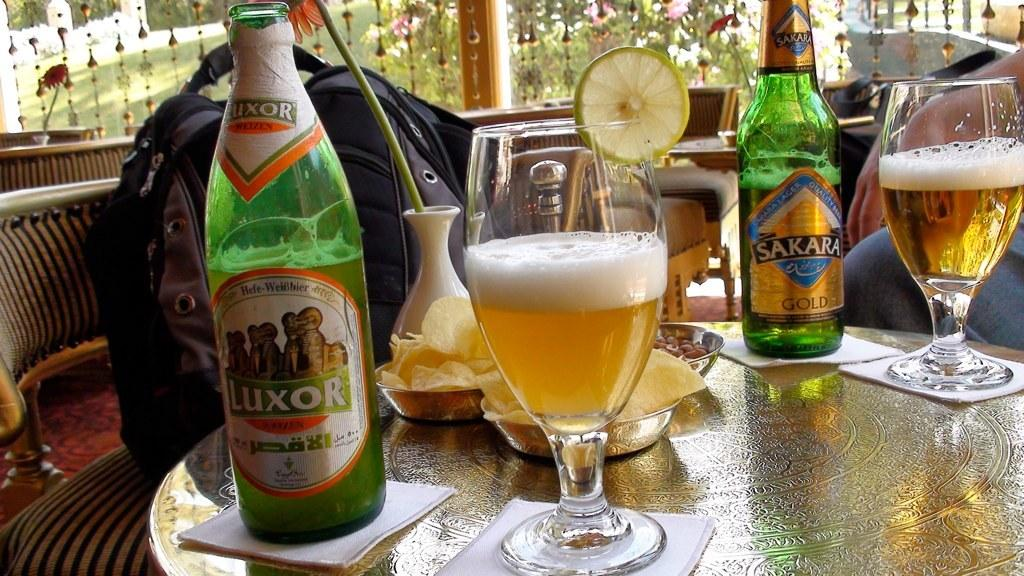<image>
Provide a brief description of the given image. A table shows two bottles, one called Luxor and two full glasses of beer. 